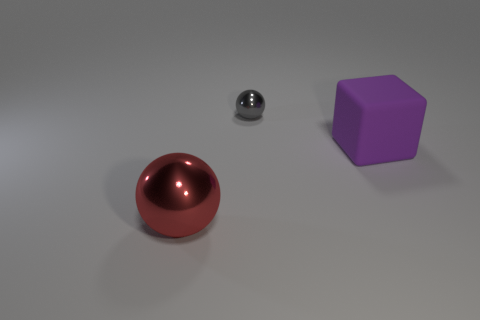Can you tell me what time of day it might be in this scene? The scene doesn't provide any indicators of a specific time of day as it seems to be an indoor studio setup with controlled lighting. The absence of windows or natural light sources makes it impossible to determine the time of day from the image. 